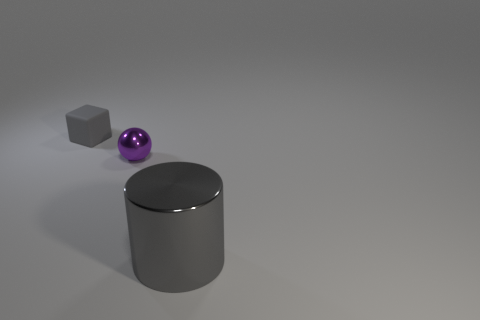Add 2 large gray metallic objects. How many objects exist? 5 Subtract all spheres. How many objects are left? 2 Subtract all tiny gray cylinders. Subtract all tiny cubes. How many objects are left? 2 Add 1 tiny gray cubes. How many tiny gray cubes are left? 2 Add 2 tiny brown shiny balls. How many tiny brown shiny balls exist? 2 Subtract 0 red cubes. How many objects are left? 3 